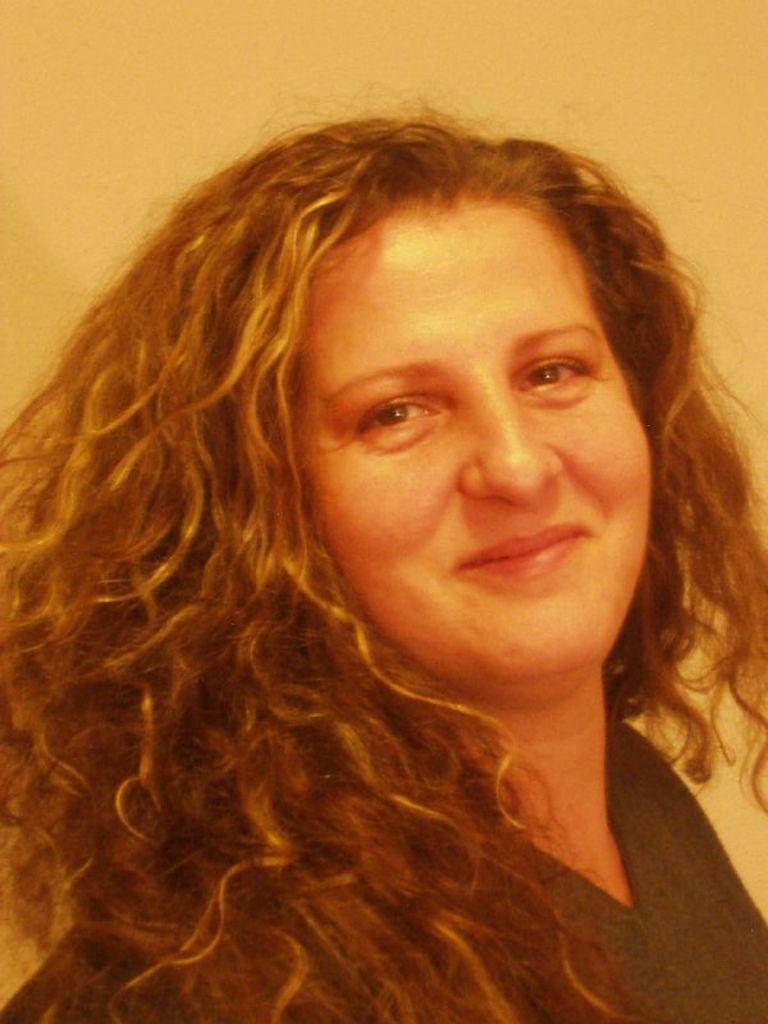Could you give a brief overview of what you see in this image? In the image there is a woman, she is smiling and the background of the woman is plain. 